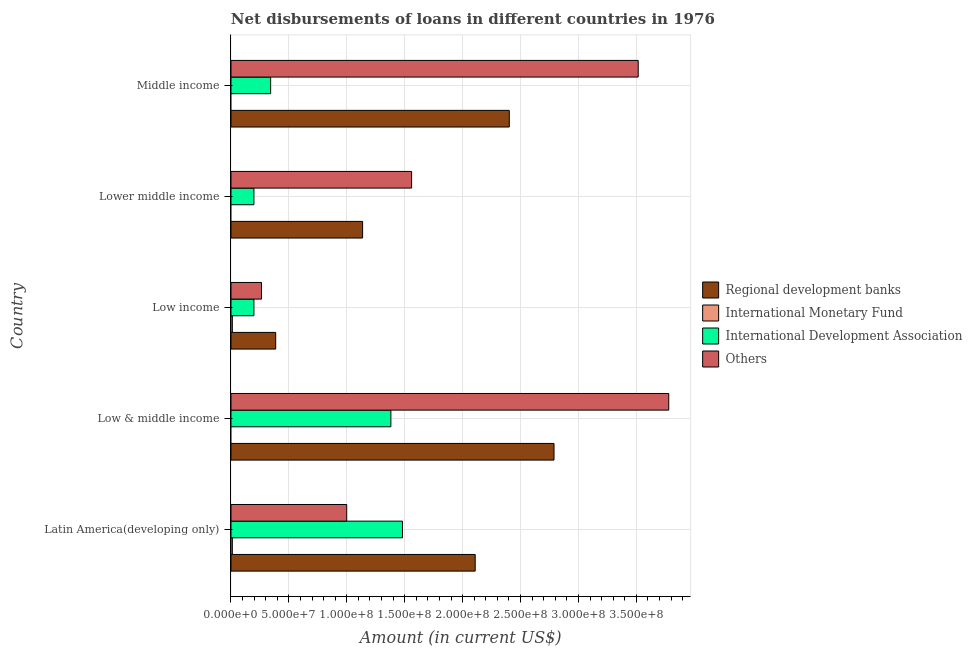What is the label of the 4th group of bars from the top?
Offer a very short reply. Low & middle income. In how many cases, is the number of bars for a given country not equal to the number of legend labels?
Give a very brief answer. 3. What is the amount of loan disimbursed by international development association in Middle income?
Keep it short and to the point. 3.42e+07. Across all countries, what is the maximum amount of loan disimbursed by other organisations?
Offer a very short reply. 3.78e+08. Across all countries, what is the minimum amount of loan disimbursed by international monetary fund?
Provide a succinct answer. 0. In which country was the amount of loan disimbursed by international monetary fund maximum?
Provide a short and direct response. Latin America(developing only). What is the total amount of loan disimbursed by international development association in the graph?
Give a very brief answer. 3.60e+08. What is the difference between the amount of loan disimbursed by international monetary fund in Latin America(developing only) and the amount of loan disimbursed by regional development banks in Low income?
Your answer should be very brief. -3.74e+07. What is the average amount of loan disimbursed by other organisations per country?
Your response must be concise. 2.02e+08. What is the difference between the amount of loan disimbursed by international development association and amount of loan disimbursed by other organisations in Middle income?
Give a very brief answer. -3.17e+08. What is the ratio of the amount of loan disimbursed by other organisations in Low income to that in Lower middle income?
Provide a short and direct response. 0.17. What is the difference between the highest and the second highest amount of loan disimbursed by other organisations?
Provide a succinct answer. 2.64e+07. What is the difference between the highest and the lowest amount of loan disimbursed by international monetary fund?
Ensure brevity in your answer.  1.18e+06. In how many countries, is the amount of loan disimbursed by regional development banks greater than the average amount of loan disimbursed by regional development banks taken over all countries?
Ensure brevity in your answer.  3. Is the sum of the amount of loan disimbursed by regional development banks in Low & middle income and Middle income greater than the maximum amount of loan disimbursed by other organisations across all countries?
Give a very brief answer. Yes. Is it the case that in every country, the sum of the amount of loan disimbursed by regional development banks and amount of loan disimbursed by international monetary fund is greater than the amount of loan disimbursed by international development association?
Provide a short and direct response. Yes. Are all the bars in the graph horizontal?
Your response must be concise. Yes. What is the difference between two consecutive major ticks on the X-axis?
Give a very brief answer. 5.00e+07. How many legend labels are there?
Make the answer very short. 4. How are the legend labels stacked?
Your answer should be very brief. Vertical. What is the title of the graph?
Your answer should be compact. Net disbursements of loans in different countries in 1976. Does "Social equity" appear as one of the legend labels in the graph?
Your answer should be compact. No. What is the Amount (in current US$) of Regional development banks in Latin America(developing only)?
Provide a succinct answer. 2.11e+08. What is the Amount (in current US$) in International Monetary Fund in Latin America(developing only)?
Make the answer very short. 1.18e+06. What is the Amount (in current US$) of International Development Association in Latin America(developing only)?
Make the answer very short. 1.48e+08. What is the Amount (in current US$) in Others in Latin America(developing only)?
Make the answer very short. 9.99e+07. What is the Amount (in current US$) in Regional development banks in Low & middle income?
Offer a very short reply. 2.79e+08. What is the Amount (in current US$) of International Development Association in Low & middle income?
Ensure brevity in your answer.  1.38e+08. What is the Amount (in current US$) of Others in Low & middle income?
Make the answer very short. 3.78e+08. What is the Amount (in current US$) of Regional development banks in Low income?
Offer a very short reply. 3.86e+07. What is the Amount (in current US$) of International Monetary Fund in Low income?
Provide a succinct answer. 1.18e+06. What is the Amount (in current US$) of International Development Association in Low income?
Make the answer very short. 1.98e+07. What is the Amount (in current US$) in Others in Low income?
Give a very brief answer. 2.64e+07. What is the Amount (in current US$) in Regional development banks in Lower middle income?
Make the answer very short. 1.14e+08. What is the Amount (in current US$) of International Monetary Fund in Lower middle income?
Provide a succinct answer. 0. What is the Amount (in current US$) of International Development Association in Lower middle income?
Give a very brief answer. 1.98e+07. What is the Amount (in current US$) of Others in Lower middle income?
Offer a terse response. 1.56e+08. What is the Amount (in current US$) of Regional development banks in Middle income?
Your answer should be very brief. 2.40e+08. What is the Amount (in current US$) of International Development Association in Middle income?
Offer a very short reply. 3.42e+07. What is the Amount (in current US$) in Others in Middle income?
Provide a succinct answer. 3.52e+08. Across all countries, what is the maximum Amount (in current US$) of Regional development banks?
Keep it short and to the point. 2.79e+08. Across all countries, what is the maximum Amount (in current US$) in International Monetary Fund?
Your answer should be compact. 1.18e+06. Across all countries, what is the maximum Amount (in current US$) in International Development Association?
Your response must be concise. 1.48e+08. Across all countries, what is the maximum Amount (in current US$) in Others?
Your response must be concise. 3.78e+08. Across all countries, what is the minimum Amount (in current US$) in Regional development banks?
Keep it short and to the point. 3.86e+07. Across all countries, what is the minimum Amount (in current US$) of International Monetary Fund?
Provide a short and direct response. 0. Across all countries, what is the minimum Amount (in current US$) of International Development Association?
Provide a succinct answer. 1.98e+07. Across all countries, what is the minimum Amount (in current US$) of Others?
Offer a very short reply. 2.64e+07. What is the total Amount (in current US$) in Regional development banks in the graph?
Keep it short and to the point. 8.82e+08. What is the total Amount (in current US$) in International Monetary Fund in the graph?
Keep it short and to the point. 2.37e+06. What is the total Amount (in current US$) in International Development Association in the graph?
Offer a very short reply. 3.60e+08. What is the total Amount (in current US$) of Others in the graph?
Your response must be concise. 1.01e+09. What is the difference between the Amount (in current US$) in Regional development banks in Latin America(developing only) and that in Low & middle income?
Your answer should be very brief. -6.80e+07. What is the difference between the Amount (in current US$) of Others in Latin America(developing only) and that in Low & middle income?
Offer a terse response. -2.78e+08. What is the difference between the Amount (in current US$) in Regional development banks in Latin America(developing only) and that in Low income?
Provide a succinct answer. 1.72e+08. What is the difference between the Amount (in current US$) in International Monetary Fund in Latin America(developing only) and that in Low income?
Give a very brief answer. 0. What is the difference between the Amount (in current US$) of International Development Association in Latin America(developing only) and that in Low income?
Offer a terse response. 1.28e+08. What is the difference between the Amount (in current US$) in Others in Latin America(developing only) and that in Low income?
Your response must be concise. 7.36e+07. What is the difference between the Amount (in current US$) in Regional development banks in Latin America(developing only) and that in Lower middle income?
Ensure brevity in your answer.  9.72e+07. What is the difference between the Amount (in current US$) of International Development Association in Latin America(developing only) and that in Lower middle income?
Ensure brevity in your answer.  1.28e+08. What is the difference between the Amount (in current US$) in Others in Latin America(developing only) and that in Lower middle income?
Make the answer very short. -5.60e+07. What is the difference between the Amount (in current US$) of Regional development banks in Latin America(developing only) and that in Middle income?
Your answer should be very brief. -2.94e+07. What is the difference between the Amount (in current US$) of International Development Association in Latin America(developing only) and that in Middle income?
Offer a terse response. 1.14e+08. What is the difference between the Amount (in current US$) in Others in Latin America(developing only) and that in Middle income?
Keep it short and to the point. -2.52e+08. What is the difference between the Amount (in current US$) of Regional development banks in Low & middle income and that in Low income?
Ensure brevity in your answer.  2.40e+08. What is the difference between the Amount (in current US$) in International Development Association in Low & middle income and that in Low income?
Your answer should be compact. 1.18e+08. What is the difference between the Amount (in current US$) in Others in Low & middle income and that in Low income?
Offer a terse response. 3.52e+08. What is the difference between the Amount (in current US$) in Regional development banks in Low & middle income and that in Lower middle income?
Provide a succinct answer. 1.65e+08. What is the difference between the Amount (in current US$) of International Development Association in Low & middle income and that in Lower middle income?
Your response must be concise. 1.18e+08. What is the difference between the Amount (in current US$) of Others in Low & middle income and that in Lower middle income?
Your answer should be compact. 2.22e+08. What is the difference between the Amount (in current US$) of Regional development banks in Low & middle income and that in Middle income?
Ensure brevity in your answer.  3.86e+07. What is the difference between the Amount (in current US$) in International Development Association in Low & middle income and that in Middle income?
Your answer should be very brief. 1.04e+08. What is the difference between the Amount (in current US$) in Others in Low & middle income and that in Middle income?
Offer a very short reply. 2.64e+07. What is the difference between the Amount (in current US$) in Regional development banks in Low income and that in Lower middle income?
Your answer should be very brief. -7.50e+07. What is the difference between the Amount (in current US$) in International Development Association in Low income and that in Lower middle income?
Provide a succinct answer. 0. What is the difference between the Amount (in current US$) in Others in Low income and that in Lower middle income?
Your response must be concise. -1.30e+08. What is the difference between the Amount (in current US$) in Regional development banks in Low income and that in Middle income?
Give a very brief answer. -2.02e+08. What is the difference between the Amount (in current US$) of International Development Association in Low income and that in Middle income?
Give a very brief answer. -1.44e+07. What is the difference between the Amount (in current US$) in Others in Low income and that in Middle income?
Make the answer very short. -3.25e+08. What is the difference between the Amount (in current US$) of Regional development banks in Lower middle income and that in Middle income?
Provide a succinct answer. -1.27e+08. What is the difference between the Amount (in current US$) in International Development Association in Lower middle income and that in Middle income?
Provide a short and direct response. -1.44e+07. What is the difference between the Amount (in current US$) in Others in Lower middle income and that in Middle income?
Provide a short and direct response. -1.96e+08. What is the difference between the Amount (in current US$) in Regional development banks in Latin America(developing only) and the Amount (in current US$) in International Development Association in Low & middle income?
Your response must be concise. 7.28e+07. What is the difference between the Amount (in current US$) in Regional development banks in Latin America(developing only) and the Amount (in current US$) in Others in Low & middle income?
Offer a terse response. -1.67e+08. What is the difference between the Amount (in current US$) in International Monetary Fund in Latin America(developing only) and the Amount (in current US$) in International Development Association in Low & middle income?
Your answer should be compact. -1.37e+08. What is the difference between the Amount (in current US$) in International Monetary Fund in Latin America(developing only) and the Amount (in current US$) in Others in Low & middle income?
Provide a succinct answer. -3.77e+08. What is the difference between the Amount (in current US$) in International Development Association in Latin America(developing only) and the Amount (in current US$) in Others in Low & middle income?
Provide a short and direct response. -2.30e+08. What is the difference between the Amount (in current US$) of Regional development banks in Latin America(developing only) and the Amount (in current US$) of International Monetary Fund in Low income?
Your response must be concise. 2.10e+08. What is the difference between the Amount (in current US$) of Regional development banks in Latin America(developing only) and the Amount (in current US$) of International Development Association in Low income?
Your answer should be very brief. 1.91e+08. What is the difference between the Amount (in current US$) in Regional development banks in Latin America(developing only) and the Amount (in current US$) in Others in Low income?
Ensure brevity in your answer.  1.85e+08. What is the difference between the Amount (in current US$) in International Monetary Fund in Latin America(developing only) and the Amount (in current US$) in International Development Association in Low income?
Make the answer very short. -1.86e+07. What is the difference between the Amount (in current US$) of International Monetary Fund in Latin America(developing only) and the Amount (in current US$) of Others in Low income?
Provide a succinct answer. -2.52e+07. What is the difference between the Amount (in current US$) in International Development Association in Latin America(developing only) and the Amount (in current US$) in Others in Low income?
Your response must be concise. 1.22e+08. What is the difference between the Amount (in current US$) of Regional development banks in Latin America(developing only) and the Amount (in current US$) of International Development Association in Lower middle income?
Make the answer very short. 1.91e+08. What is the difference between the Amount (in current US$) of Regional development banks in Latin America(developing only) and the Amount (in current US$) of Others in Lower middle income?
Ensure brevity in your answer.  5.49e+07. What is the difference between the Amount (in current US$) of International Monetary Fund in Latin America(developing only) and the Amount (in current US$) of International Development Association in Lower middle income?
Ensure brevity in your answer.  -1.86e+07. What is the difference between the Amount (in current US$) of International Monetary Fund in Latin America(developing only) and the Amount (in current US$) of Others in Lower middle income?
Offer a very short reply. -1.55e+08. What is the difference between the Amount (in current US$) in International Development Association in Latin America(developing only) and the Amount (in current US$) in Others in Lower middle income?
Your answer should be very brief. -7.89e+06. What is the difference between the Amount (in current US$) of Regional development banks in Latin America(developing only) and the Amount (in current US$) of International Development Association in Middle income?
Give a very brief answer. 1.77e+08. What is the difference between the Amount (in current US$) of Regional development banks in Latin America(developing only) and the Amount (in current US$) of Others in Middle income?
Offer a terse response. -1.41e+08. What is the difference between the Amount (in current US$) of International Monetary Fund in Latin America(developing only) and the Amount (in current US$) of International Development Association in Middle income?
Your response must be concise. -3.31e+07. What is the difference between the Amount (in current US$) of International Monetary Fund in Latin America(developing only) and the Amount (in current US$) of Others in Middle income?
Provide a succinct answer. -3.50e+08. What is the difference between the Amount (in current US$) in International Development Association in Latin America(developing only) and the Amount (in current US$) in Others in Middle income?
Provide a short and direct response. -2.04e+08. What is the difference between the Amount (in current US$) of Regional development banks in Low & middle income and the Amount (in current US$) of International Monetary Fund in Low income?
Offer a terse response. 2.78e+08. What is the difference between the Amount (in current US$) of Regional development banks in Low & middle income and the Amount (in current US$) of International Development Association in Low income?
Keep it short and to the point. 2.59e+08. What is the difference between the Amount (in current US$) in Regional development banks in Low & middle income and the Amount (in current US$) in Others in Low income?
Offer a very short reply. 2.53e+08. What is the difference between the Amount (in current US$) in International Development Association in Low & middle income and the Amount (in current US$) in Others in Low income?
Provide a short and direct response. 1.12e+08. What is the difference between the Amount (in current US$) of Regional development banks in Low & middle income and the Amount (in current US$) of International Development Association in Lower middle income?
Offer a terse response. 2.59e+08. What is the difference between the Amount (in current US$) in Regional development banks in Low & middle income and the Amount (in current US$) in Others in Lower middle income?
Your response must be concise. 1.23e+08. What is the difference between the Amount (in current US$) in International Development Association in Low & middle income and the Amount (in current US$) in Others in Lower middle income?
Keep it short and to the point. -1.79e+07. What is the difference between the Amount (in current US$) in Regional development banks in Low & middle income and the Amount (in current US$) in International Development Association in Middle income?
Ensure brevity in your answer.  2.45e+08. What is the difference between the Amount (in current US$) in Regional development banks in Low & middle income and the Amount (in current US$) in Others in Middle income?
Provide a succinct answer. -7.27e+07. What is the difference between the Amount (in current US$) in International Development Association in Low & middle income and the Amount (in current US$) in Others in Middle income?
Provide a succinct answer. -2.14e+08. What is the difference between the Amount (in current US$) in Regional development banks in Low income and the Amount (in current US$) in International Development Association in Lower middle income?
Your answer should be compact. 1.88e+07. What is the difference between the Amount (in current US$) in Regional development banks in Low income and the Amount (in current US$) in Others in Lower middle income?
Provide a succinct answer. -1.17e+08. What is the difference between the Amount (in current US$) in International Monetary Fund in Low income and the Amount (in current US$) in International Development Association in Lower middle income?
Ensure brevity in your answer.  -1.86e+07. What is the difference between the Amount (in current US$) in International Monetary Fund in Low income and the Amount (in current US$) in Others in Lower middle income?
Provide a short and direct response. -1.55e+08. What is the difference between the Amount (in current US$) of International Development Association in Low income and the Amount (in current US$) of Others in Lower middle income?
Your answer should be very brief. -1.36e+08. What is the difference between the Amount (in current US$) in Regional development banks in Low income and the Amount (in current US$) in International Development Association in Middle income?
Your response must be concise. 4.38e+06. What is the difference between the Amount (in current US$) in Regional development banks in Low income and the Amount (in current US$) in Others in Middle income?
Ensure brevity in your answer.  -3.13e+08. What is the difference between the Amount (in current US$) of International Monetary Fund in Low income and the Amount (in current US$) of International Development Association in Middle income?
Provide a short and direct response. -3.31e+07. What is the difference between the Amount (in current US$) of International Monetary Fund in Low income and the Amount (in current US$) of Others in Middle income?
Provide a short and direct response. -3.50e+08. What is the difference between the Amount (in current US$) in International Development Association in Low income and the Amount (in current US$) in Others in Middle income?
Keep it short and to the point. -3.32e+08. What is the difference between the Amount (in current US$) of Regional development banks in Lower middle income and the Amount (in current US$) of International Development Association in Middle income?
Ensure brevity in your answer.  7.94e+07. What is the difference between the Amount (in current US$) of Regional development banks in Lower middle income and the Amount (in current US$) of Others in Middle income?
Ensure brevity in your answer.  -2.38e+08. What is the difference between the Amount (in current US$) in International Development Association in Lower middle income and the Amount (in current US$) in Others in Middle income?
Offer a terse response. -3.32e+08. What is the average Amount (in current US$) in Regional development banks per country?
Keep it short and to the point. 1.76e+08. What is the average Amount (in current US$) in International Monetary Fund per country?
Make the answer very short. 4.73e+05. What is the average Amount (in current US$) of International Development Association per country?
Your answer should be compact. 7.20e+07. What is the average Amount (in current US$) in Others per country?
Keep it short and to the point. 2.02e+08. What is the difference between the Amount (in current US$) of Regional development banks and Amount (in current US$) of International Monetary Fund in Latin America(developing only)?
Your answer should be very brief. 2.10e+08. What is the difference between the Amount (in current US$) in Regional development banks and Amount (in current US$) in International Development Association in Latin America(developing only)?
Your answer should be very brief. 6.28e+07. What is the difference between the Amount (in current US$) in Regional development banks and Amount (in current US$) in Others in Latin America(developing only)?
Ensure brevity in your answer.  1.11e+08. What is the difference between the Amount (in current US$) of International Monetary Fund and Amount (in current US$) of International Development Association in Latin America(developing only)?
Make the answer very short. -1.47e+08. What is the difference between the Amount (in current US$) of International Monetary Fund and Amount (in current US$) of Others in Latin America(developing only)?
Provide a succinct answer. -9.88e+07. What is the difference between the Amount (in current US$) in International Development Association and Amount (in current US$) in Others in Latin America(developing only)?
Your response must be concise. 4.81e+07. What is the difference between the Amount (in current US$) in Regional development banks and Amount (in current US$) in International Development Association in Low & middle income?
Your answer should be compact. 1.41e+08. What is the difference between the Amount (in current US$) in Regional development banks and Amount (in current US$) in Others in Low & middle income?
Give a very brief answer. -9.91e+07. What is the difference between the Amount (in current US$) of International Development Association and Amount (in current US$) of Others in Low & middle income?
Offer a very short reply. -2.40e+08. What is the difference between the Amount (in current US$) in Regional development banks and Amount (in current US$) in International Monetary Fund in Low income?
Your answer should be very brief. 3.74e+07. What is the difference between the Amount (in current US$) of Regional development banks and Amount (in current US$) of International Development Association in Low income?
Keep it short and to the point. 1.88e+07. What is the difference between the Amount (in current US$) of Regional development banks and Amount (in current US$) of Others in Low income?
Keep it short and to the point. 1.23e+07. What is the difference between the Amount (in current US$) in International Monetary Fund and Amount (in current US$) in International Development Association in Low income?
Offer a very short reply. -1.86e+07. What is the difference between the Amount (in current US$) of International Monetary Fund and Amount (in current US$) of Others in Low income?
Provide a succinct answer. -2.52e+07. What is the difference between the Amount (in current US$) of International Development Association and Amount (in current US$) of Others in Low income?
Offer a terse response. -6.55e+06. What is the difference between the Amount (in current US$) of Regional development banks and Amount (in current US$) of International Development Association in Lower middle income?
Provide a succinct answer. 9.38e+07. What is the difference between the Amount (in current US$) in Regional development banks and Amount (in current US$) in Others in Lower middle income?
Make the answer very short. -4.23e+07. What is the difference between the Amount (in current US$) in International Development Association and Amount (in current US$) in Others in Lower middle income?
Your answer should be compact. -1.36e+08. What is the difference between the Amount (in current US$) in Regional development banks and Amount (in current US$) in International Development Association in Middle income?
Ensure brevity in your answer.  2.06e+08. What is the difference between the Amount (in current US$) in Regional development banks and Amount (in current US$) in Others in Middle income?
Your answer should be compact. -1.11e+08. What is the difference between the Amount (in current US$) in International Development Association and Amount (in current US$) in Others in Middle income?
Give a very brief answer. -3.17e+08. What is the ratio of the Amount (in current US$) in Regional development banks in Latin America(developing only) to that in Low & middle income?
Give a very brief answer. 0.76. What is the ratio of the Amount (in current US$) in International Development Association in Latin America(developing only) to that in Low & middle income?
Your answer should be compact. 1.07. What is the ratio of the Amount (in current US$) in Others in Latin America(developing only) to that in Low & middle income?
Offer a very short reply. 0.26. What is the ratio of the Amount (in current US$) in Regional development banks in Latin America(developing only) to that in Low income?
Your answer should be compact. 5.46. What is the ratio of the Amount (in current US$) of International Development Association in Latin America(developing only) to that in Low income?
Give a very brief answer. 7.47. What is the ratio of the Amount (in current US$) of Others in Latin America(developing only) to that in Low income?
Ensure brevity in your answer.  3.79. What is the ratio of the Amount (in current US$) in Regional development banks in Latin America(developing only) to that in Lower middle income?
Your answer should be very brief. 1.86. What is the ratio of the Amount (in current US$) of International Development Association in Latin America(developing only) to that in Lower middle income?
Offer a very short reply. 7.47. What is the ratio of the Amount (in current US$) in Others in Latin America(developing only) to that in Lower middle income?
Ensure brevity in your answer.  0.64. What is the ratio of the Amount (in current US$) of Regional development banks in Latin America(developing only) to that in Middle income?
Provide a succinct answer. 0.88. What is the ratio of the Amount (in current US$) of International Development Association in Latin America(developing only) to that in Middle income?
Provide a short and direct response. 4.32. What is the ratio of the Amount (in current US$) of Others in Latin America(developing only) to that in Middle income?
Your response must be concise. 0.28. What is the ratio of the Amount (in current US$) in Regional development banks in Low & middle income to that in Low income?
Your answer should be very brief. 7.22. What is the ratio of the Amount (in current US$) in International Development Association in Low & middle income to that in Low income?
Provide a short and direct response. 6.97. What is the ratio of the Amount (in current US$) in Others in Low & middle income to that in Low income?
Provide a succinct answer. 14.34. What is the ratio of the Amount (in current US$) of Regional development banks in Low & middle income to that in Lower middle income?
Provide a succinct answer. 2.45. What is the ratio of the Amount (in current US$) of International Development Association in Low & middle income to that in Lower middle income?
Ensure brevity in your answer.  6.97. What is the ratio of the Amount (in current US$) in Others in Low & middle income to that in Lower middle income?
Offer a terse response. 2.42. What is the ratio of the Amount (in current US$) of Regional development banks in Low & middle income to that in Middle income?
Make the answer very short. 1.16. What is the ratio of the Amount (in current US$) of International Development Association in Low & middle income to that in Middle income?
Offer a terse response. 4.03. What is the ratio of the Amount (in current US$) in Others in Low & middle income to that in Middle income?
Make the answer very short. 1.07. What is the ratio of the Amount (in current US$) of Regional development banks in Low income to that in Lower middle income?
Make the answer very short. 0.34. What is the ratio of the Amount (in current US$) in Others in Low income to that in Lower middle income?
Provide a short and direct response. 0.17. What is the ratio of the Amount (in current US$) in Regional development banks in Low income to that in Middle income?
Offer a terse response. 0.16. What is the ratio of the Amount (in current US$) of International Development Association in Low income to that in Middle income?
Provide a short and direct response. 0.58. What is the ratio of the Amount (in current US$) of Others in Low income to that in Middle income?
Your response must be concise. 0.07. What is the ratio of the Amount (in current US$) of Regional development banks in Lower middle income to that in Middle income?
Your answer should be very brief. 0.47. What is the ratio of the Amount (in current US$) in International Development Association in Lower middle income to that in Middle income?
Provide a short and direct response. 0.58. What is the ratio of the Amount (in current US$) of Others in Lower middle income to that in Middle income?
Provide a succinct answer. 0.44. What is the difference between the highest and the second highest Amount (in current US$) of Regional development banks?
Keep it short and to the point. 3.86e+07. What is the difference between the highest and the second highest Amount (in current US$) of Others?
Keep it short and to the point. 2.64e+07. What is the difference between the highest and the lowest Amount (in current US$) of Regional development banks?
Your response must be concise. 2.40e+08. What is the difference between the highest and the lowest Amount (in current US$) in International Monetary Fund?
Offer a terse response. 1.18e+06. What is the difference between the highest and the lowest Amount (in current US$) in International Development Association?
Offer a terse response. 1.28e+08. What is the difference between the highest and the lowest Amount (in current US$) of Others?
Keep it short and to the point. 3.52e+08. 